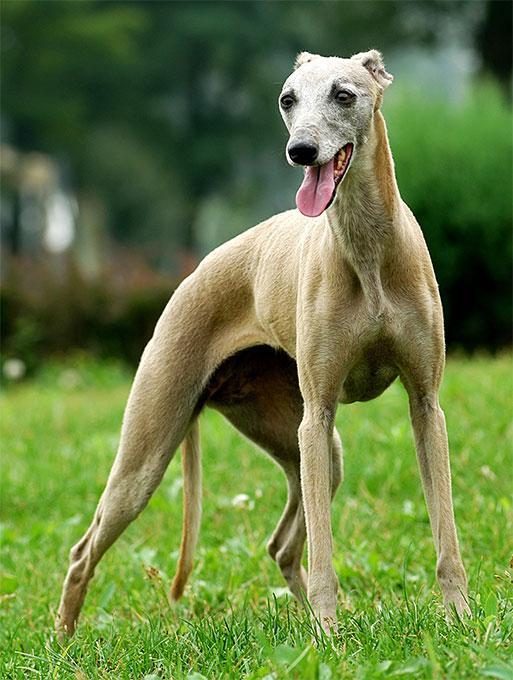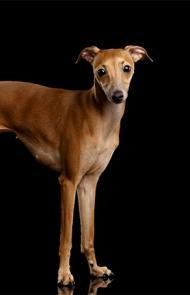The first image is the image on the left, the second image is the image on the right. Given the left and right images, does the statement "The right image shows a hound with its body touched by something beige that is soft and ribbed." hold true? Answer yes or no. No. The first image is the image on the left, the second image is the image on the right. Analyze the images presented: Is the assertion "A Miniature Grehound dog is shown laying down in at least one of the images." valid? Answer yes or no. No. 